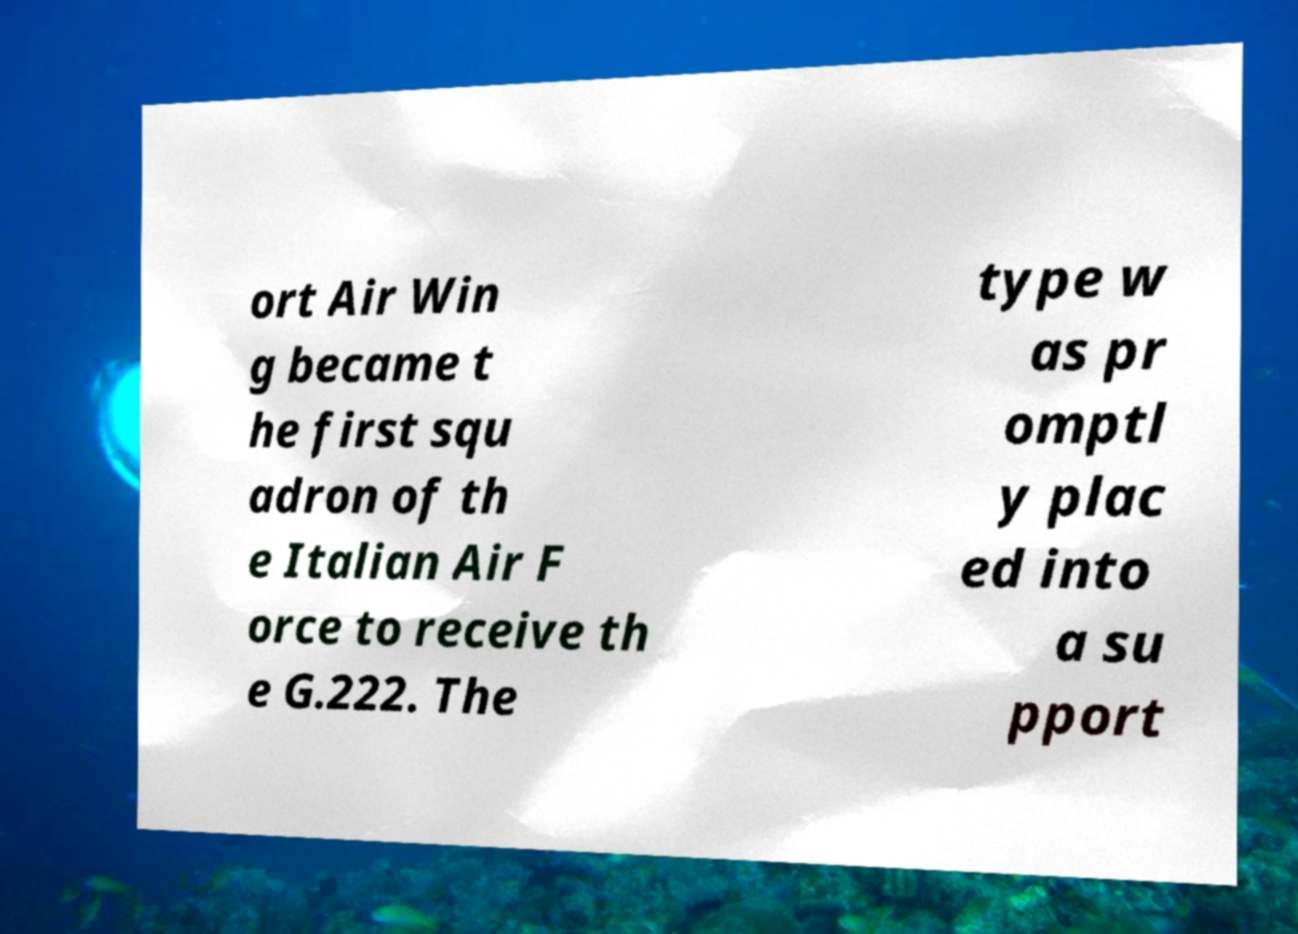Could you extract and type out the text from this image? ort Air Win g became t he first squ adron of th e Italian Air F orce to receive th e G.222. The type w as pr omptl y plac ed into a su pport 